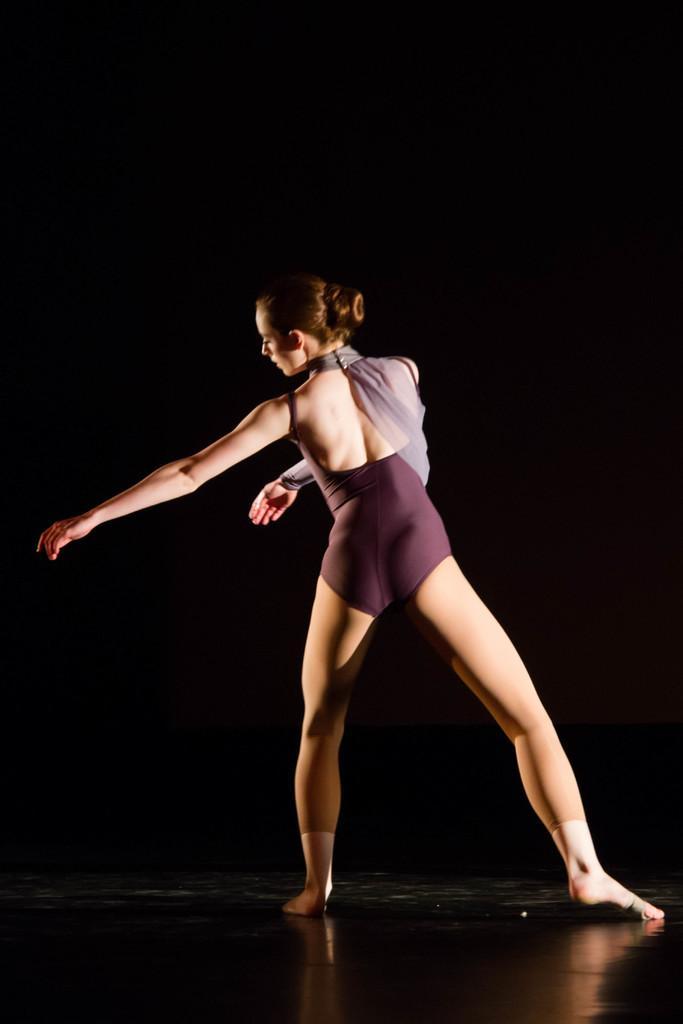How would you summarize this image in a sentence or two? In this image we can see a lady person wearing bikini dancing on floor. 